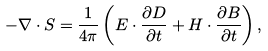<formula> <loc_0><loc_0><loc_500><loc_500>- \nabla \cdot { S } = \frac { 1 } { 4 \pi } \left ( { E } \cdot \frac { \partial { D } } { \partial t } + { H } \cdot \frac { \partial { B } } { \partial t } \right ) ,</formula> 